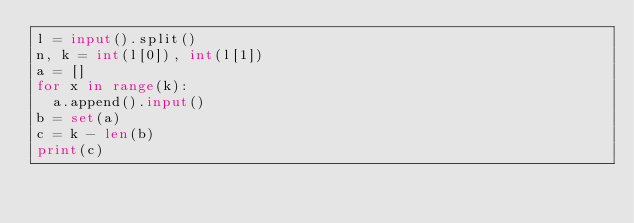<code> <loc_0><loc_0><loc_500><loc_500><_Python_>l = input().split()
n, k = int(l[0]), int(l[1])
a = []
for x in range(k):
  a.append().input()
b = set(a)
c = k - len(b)
print(c)
</code> 